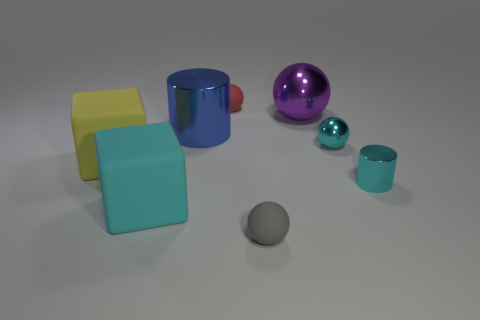What number of small shiny objects are the same color as the small metal cylinder?
Keep it short and to the point. 1. Are there fewer big blue shiny things than large blocks?
Offer a very short reply. Yes. Does the gray thing have the same material as the cyan cylinder?
Give a very brief answer. No. What number of other objects are there of the same size as the yellow cube?
Keep it short and to the point. 3. What is the color of the small matte ball behind the tiny cyan shiny thing that is in front of the cyan shiny sphere?
Give a very brief answer. Red. How many other things are there of the same shape as the yellow matte thing?
Offer a very short reply. 1. Is there a large cylinder that has the same material as the tiny cyan sphere?
Your answer should be very brief. Yes. What material is the gray thing that is the same size as the red thing?
Provide a short and direct response. Rubber. The small matte thing that is right of the matte ball behind the small matte ball that is right of the small red rubber object is what color?
Keep it short and to the point. Gray. Is the shape of the small cyan object that is in front of the yellow matte cube the same as the metal thing that is to the left of the large purple ball?
Give a very brief answer. Yes. 